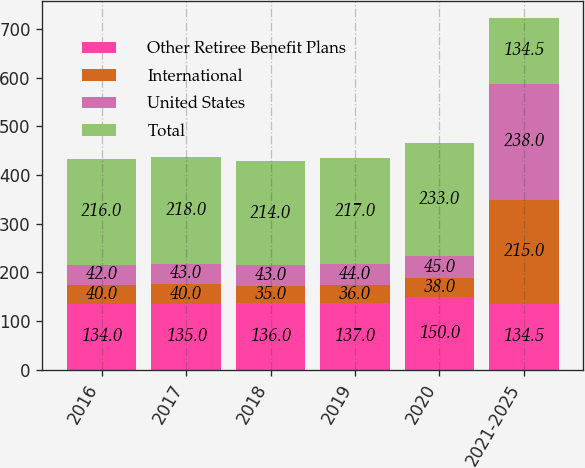Convert chart to OTSL. <chart><loc_0><loc_0><loc_500><loc_500><stacked_bar_chart><ecel><fcel>2016<fcel>2017<fcel>2018<fcel>2019<fcel>2020<fcel>2021-2025<nl><fcel>Other Retiree Benefit Plans<fcel>134<fcel>135<fcel>136<fcel>137<fcel>150<fcel>134.5<nl><fcel>International<fcel>40<fcel>40<fcel>35<fcel>36<fcel>38<fcel>215<nl><fcel>United States<fcel>42<fcel>43<fcel>43<fcel>44<fcel>45<fcel>238<nl><fcel>Total<fcel>216<fcel>218<fcel>214<fcel>217<fcel>233<fcel>134.5<nl></chart> 